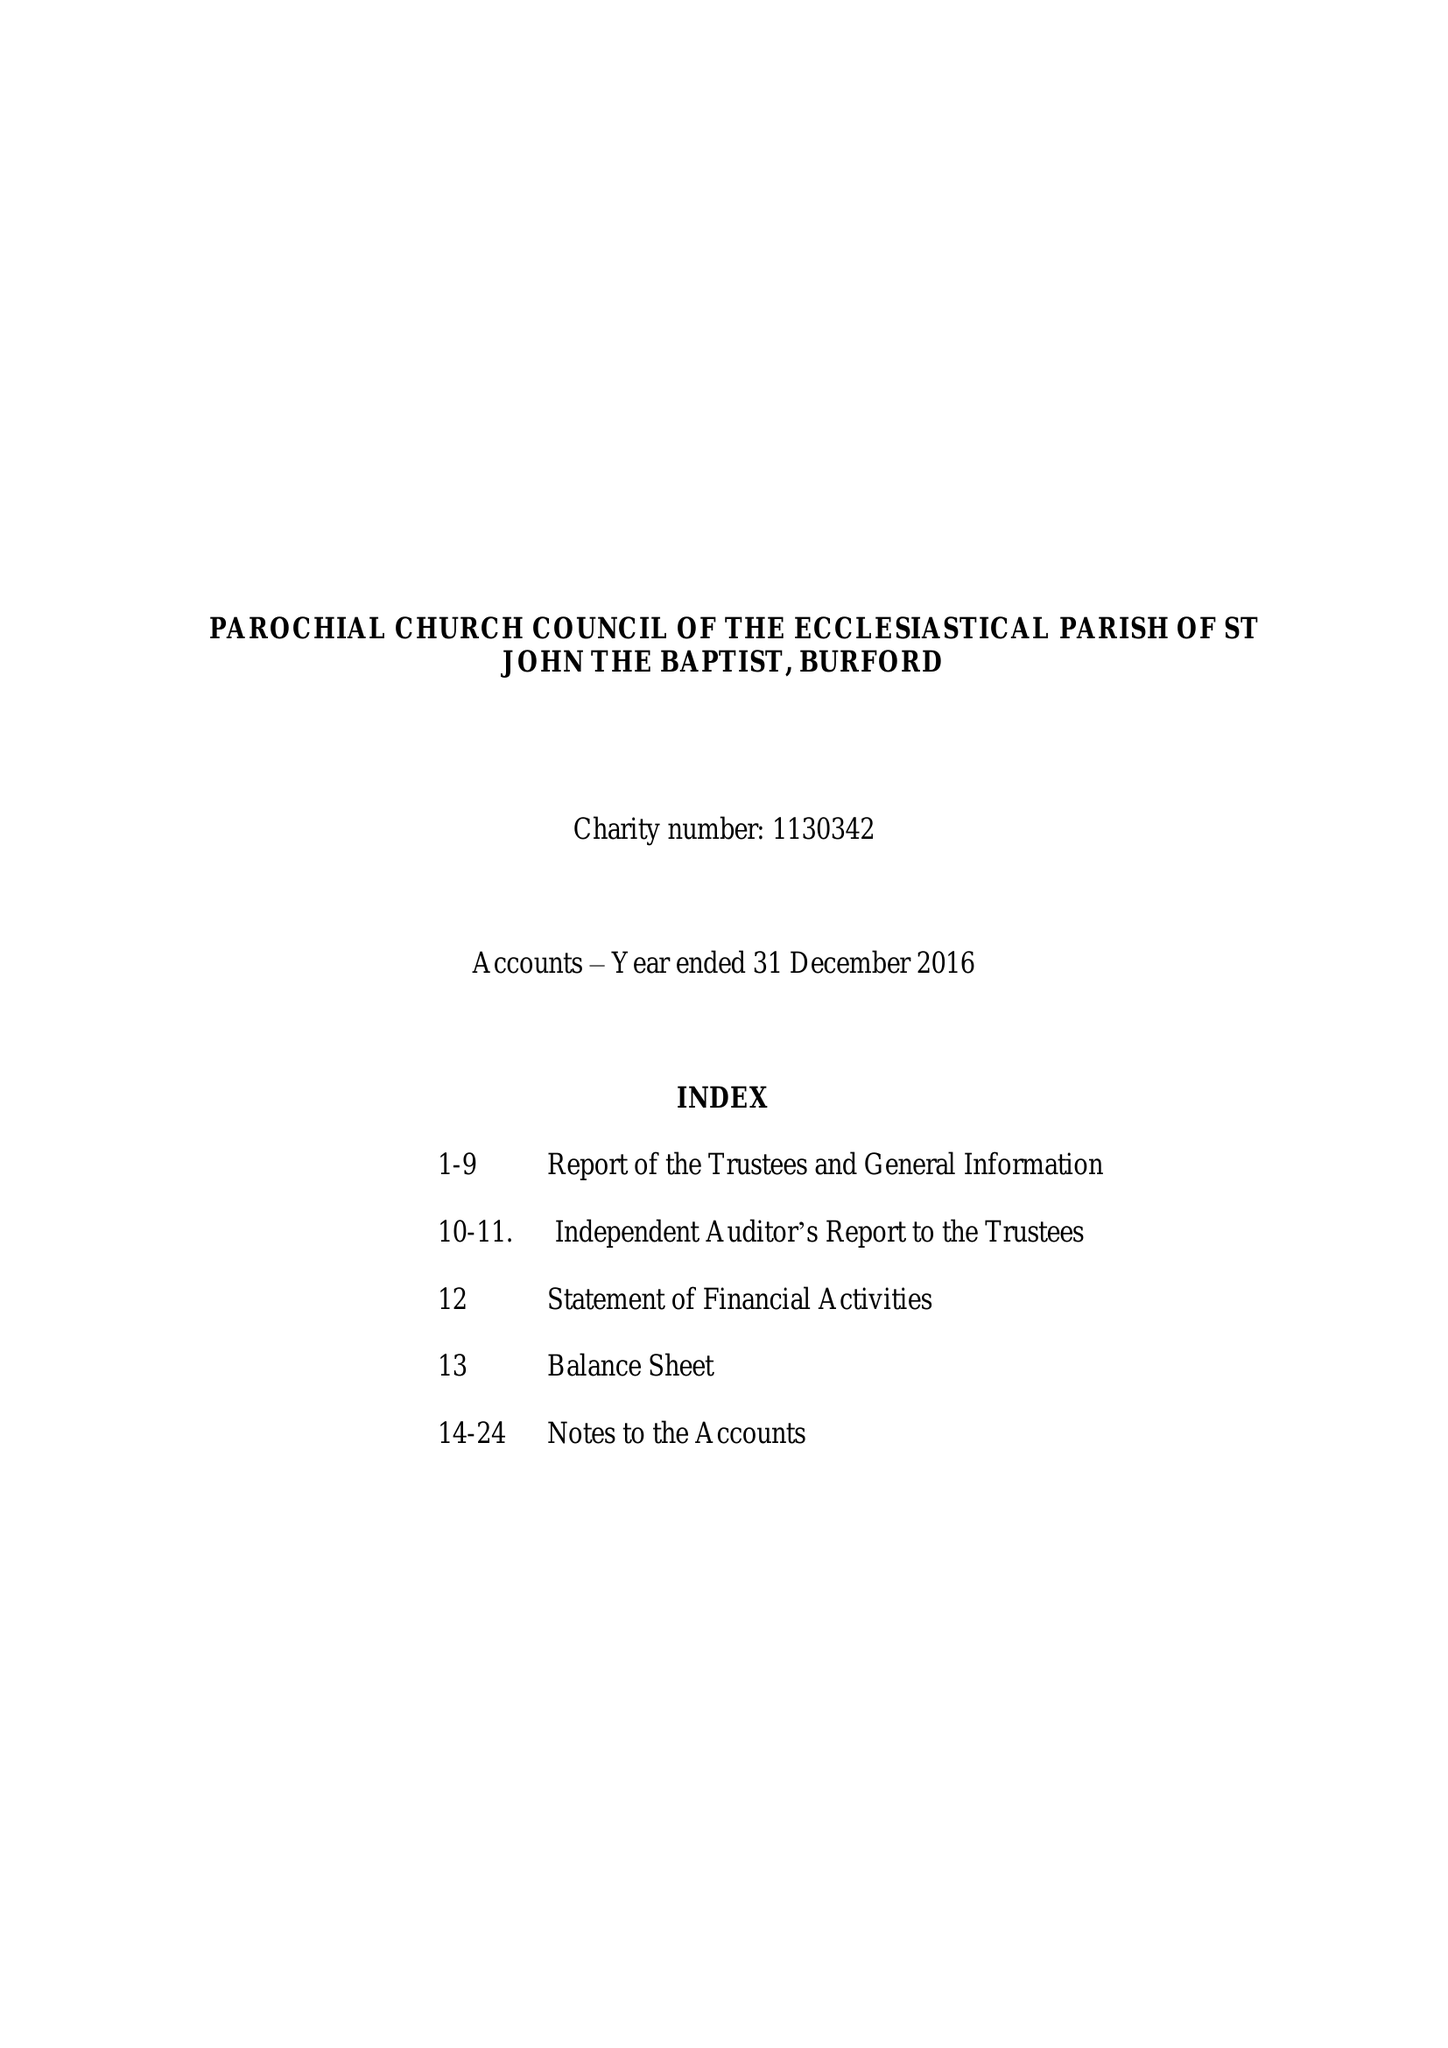What is the value for the income_annually_in_british_pounds?
Answer the question using a single word or phrase. 1023126.00 